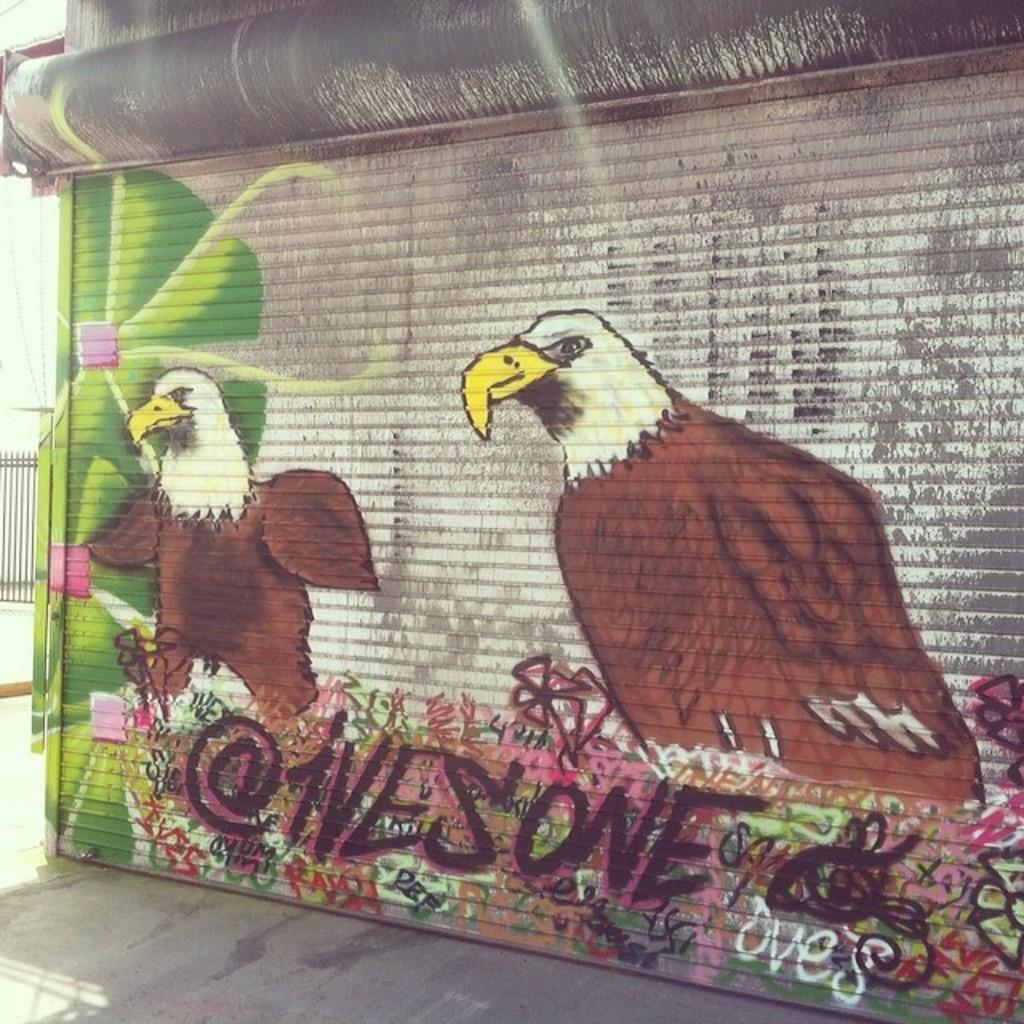What can be seen in the center of the image? There is a wall and fence in the center of the image. What is on the wall? There is some art on the wall. What types of images are included in the art on the wall? The art on the wall includes birds and flowers. What type of hammer is being used by the friend in the image? There is no friend or hammer present in the image; it only features a wall, fence, and art on the wall. 